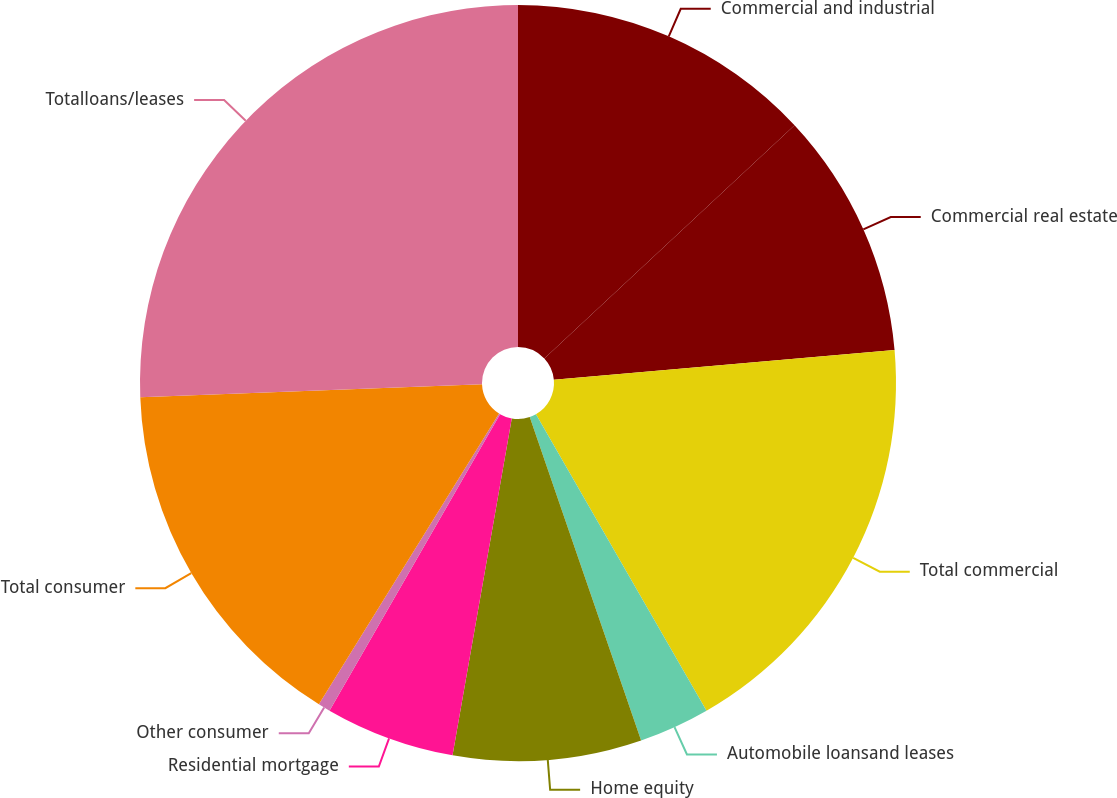<chart> <loc_0><loc_0><loc_500><loc_500><pie_chart><fcel>Commercial and industrial<fcel>Commercial real estate<fcel>Total commercial<fcel>Automobile loansand leases<fcel>Home equity<fcel>Residential mortgage<fcel>Other consumer<fcel>Total consumer<fcel>Totalloans/leases<nl><fcel>13.06%<fcel>10.55%<fcel>18.08%<fcel>3.03%<fcel>8.05%<fcel>5.54%<fcel>0.52%<fcel>15.57%<fcel>25.6%<nl></chart> 